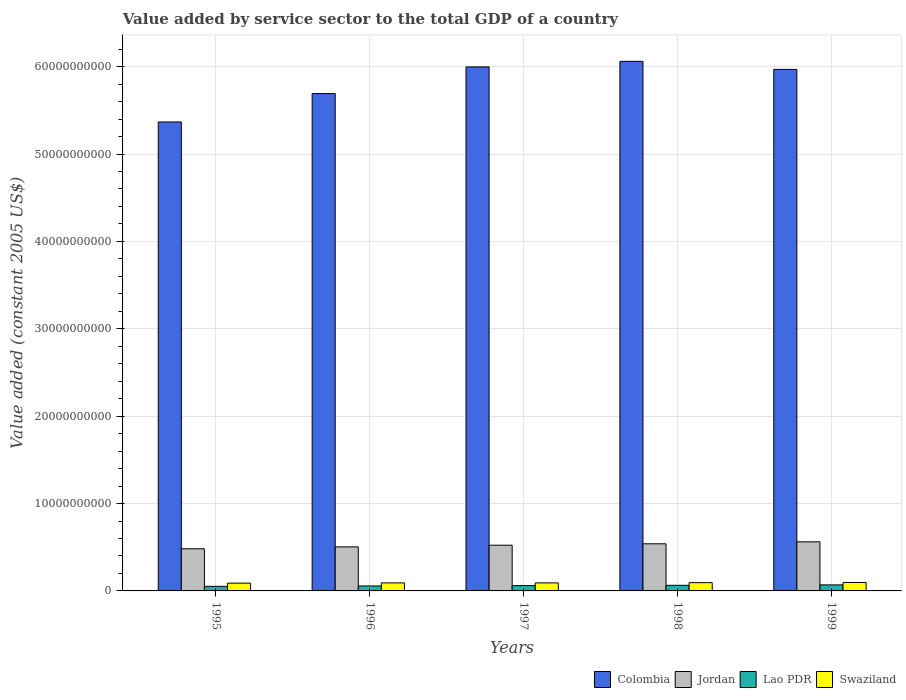How many different coloured bars are there?
Keep it short and to the point. 4. Are the number of bars per tick equal to the number of legend labels?
Your answer should be compact. Yes. Are the number of bars on each tick of the X-axis equal?
Provide a short and direct response. Yes. What is the label of the 3rd group of bars from the left?
Provide a succinct answer. 1997. What is the value added by service sector in Colombia in 1997?
Provide a succinct answer. 6.00e+1. Across all years, what is the maximum value added by service sector in Colombia?
Your answer should be compact. 6.06e+1. Across all years, what is the minimum value added by service sector in Swaziland?
Your answer should be very brief. 8.89e+08. What is the total value added by service sector in Lao PDR in the graph?
Make the answer very short. 3.04e+09. What is the difference between the value added by service sector in Colombia in 1996 and that in 1999?
Offer a very short reply. -2.77e+09. What is the difference between the value added by service sector in Colombia in 1998 and the value added by service sector in Lao PDR in 1999?
Offer a terse response. 5.99e+1. What is the average value added by service sector in Lao PDR per year?
Make the answer very short. 6.07e+08. In the year 1997, what is the difference between the value added by service sector in Swaziland and value added by service sector in Jordan?
Keep it short and to the point. -4.31e+09. In how many years, is the value added by service sector in Lao PDR greater than 8000000000 US$?
Give a very brief answer. 0. What is the ratio of the value added by service sector in Swaziland in 1995 to that in 1997?
Provide a succinct answer. 0.97. Is the value added by service sector in Lao PDR in 1997 less than that in 1999?
Ensure brevity in your answer.  Yes. Is the difference between the value added by service sector in Swaziland in 1996 and 1999 greater than the difference between the value added by service sector in Jordan in 1996 and 1999?
Ensure brevity in your answer.  Yes. What is the difference between the highest and the second highest value added by service sector in Colombia?
Make the answer very short. 6.36e+08. What is the difference between the highest and the lowest value added by service sector in Lao PDR?
Offer a very short reply. 1.65e+08. Is it the case that in every year, the sum of the value added by service sector in Swaziland and value added by service sector in Jordan is greater than the sum of value added by service sector in Colombia and value added by service sector in Lao PDR?
Ensure brevity in your answer.  No. What does the 3rd bar from the left in 1995 represents?
Provide a short and direct response. Lao PDR. What does the 1st bar from the right in 1997 represents?
Your answer should be compact. Swaziland. How many bars are there?
Your answer should be very brief. 20. Are all the bars in the graph horizontal?
Offer a very short reply. No. How many years are there in the graph?
Your response must be concise. 5. What is the difference between two consecutive major ticks on the Y-axis?
Give a very brief answer. 1.00e+1. Does the graph contain any zero values?
Make the answer very short. No. How many legend labels are there?
Keep it short and to the point. 4. What is the title of the graph?
Offer a very short reply. Value added by service sector to the total GDP of a country. What is the label or title of the Y-axis?
Your answer should be very brief. Value added (constant 2005 US$). What is the Value added (constant 2005 US$) in Colombia in 1995?
Offer a terse response. 5.37e+1. What is the Value added (constant 2005 US$) of Jordan in 1995?
Your response must be concise. 4.82e+09. What is the Value added (constant 2005 US$) of Lao PDR in 1995?
Provide a short and direct response. 5.25e+08. What is the Value added (constant 2005 US$) in Swaziland in 1995?
Your response must be concise. 8.89e+08. What is the Value added (constant 2005 US$) of Colombia in 1996?
Give a very brief answer. 5.69e+1. What is the Value added (constant 2005 US$) of Jordan in 1996?
Offer a very short reply. 5.04e+09. What is the Value added (constant 2005 US$) of Lao PDR in 1996?
Your answer should be compact. 5.68e+08. What is the Value added (constant 2005 US$) of Swaziland in 1996?
Your response must be concise. 9.19e+08. What is the Value added (constant 2005 US$) in Colombia in 1997?
Your answer should be very brief. 6.00e+1. What is the Value added (constant 2005 US$) in Jordan in 1997?
Your answer should be compact. 5.23e+09. What is the Value added (constant 2005 US$) in Lao PDR in 1997?
Provide a short and direct response. 6.11e+08. What is the Value added (constant 2005 US$) of Swaziland in 1997?
Provide a short and direct response. 9.18e+08. What is the Value added (constant 2005 US$) of Colombia in 1998?
Offer a terse response. 6.06e+1. What is the Value added (constant 2005 US$) of Jordan in 1998?
Offer a terse response. 5.39e+09. What is the Value added (constant 2005 US$) of Lao PDR in 1998?
Your response must be concise. 6.41e+08. What is the Value added (constant 2005 US$) in Swaziland in 1998?
Make the answer very short. 9.46e+08. What is the Value added (constant 2005 US$) of Colombia in 1999?
Give a very brief answer. 5.97e+1. What is the Value added (constant 2005 US$) in Jordan in 1999?
Keep it short and to the point. 5.62e+09. What is the Value added (constant 2005 US$) of Lao PDR in 1999?
Make the answer very short. 6.90e+08. What is the Value added (constant 2005 US$) of Swaziland in 1999?
Keep it short and to the point. 9.68e+08. Across all years, what is the maximum Value added (constant 2005 US$) in Colombia?
Your answer should be very brief. 6.06e+1. Across all years, what is the maximum Value added (constant 2005 US$) in Jordan?
Give a very brief answer. 5.62e+09. Across all years, what is the maximum Value added (constant 2005 US$) of Lao PDR?
Give a very brief answer. 6.90e+08. Across all years, what is the maximum Value added (constant 2005 US$) of Swaziland?
Your answer should be compact. 9.68e+08. Across all years, what is the minimum Value added (constant 2005 US$) of Colombia?
Keep it short and to the point. 5.37e+1. Across all years, what is the minimum Value added (constant 2005 US$) of Jordan?
Provide a short and direct response. 4.82e+09. Across all years, what is the minimum Value added (constant 2005 US$) in Lao PDR?
Provide a succinct answer. 5.25e+08. Across all years, what is the minimum Value added (constant 2005 US$) in Swaziland?
Provide a succinct answer. 8.89e+08. What is the total Value added (constant 2005 US$) of Colombia in the graph?
Your response must be concise. 2.91e+11. What is the total Value added (constant 2005 US$) in Jordan in the graph?
Your answer should be compact. 2.61e+1. What is the total Value added (constant 2005 US$) of Lao PDR in the graph?
Provide a short and direct response. 3.04e+09. What is the total Value added (constant 2005 US$) in Swaziland in the graph?
Offer a terse response. 4.64e+09. What is the difference between the Value added (constant 2005 US$) of Colombia in 1995 and that in 1996?
Provide a short and direct response. -3.25e+09. What is the difference between the Value added (constant 2005 US$) in Jordan in 1995 and that in 1996?
Your response must be concise. -2.20e+08. What is the difference between the Value added (constant 2005 US$) in Lao PDR in 1995 and that in 1996?
Offer a terse response. -4.25e+07. What is the difference between the Value added (constant 2005 US$) of Swaziland in 1995 and that in 1996?
Offer a terse response. -3.01e+07. What is the difference between the Value added (constant 2005 US$) of Colombia in 1995 and that in 1997?
Offer a very short reply. -6.30e+09. What is the difference between the Value added (constant 2005 US$) of Jordan in 1995 and that in 1997?
Your answer should be compact. -4.09e+08. What is the difference between the Value added (constant 2005 US$) of Lao PDR in 1995 and that in 1997?
Your response must be concise. -8.52e+07. What is the difference between the Value added (constant 2005 US$) of Swaziland in 1995 and that in 1997?
Your response must be concise. -2.96e+07. What is the difference between the Value added (constant 2005 US$) of Colombia in 1995 and that in 1998?
Your answer should be very brief. -6.94e+09. What is the difference between the Value added (constant 2005 US$) of Jordan in 1995 and that in 1998?
Ensure brevity in your answer.  -5.69e+08. What is the difference between the Value added (constant 2005 US$) in Lao PDR in 1995 and that in 1998?
Provide a succinct answer. -1.15e+08. What is the difference between the Value added (constant 2005 US$) in Swaziland in 1995 and that in 1998?
Offer a very short reply. -5.75e+07. What is the difference between the Value added (constant 2005 US$) in Colombia in 1995 and that in 1999?
Your answer should be compact. -6.02e+09. What is the difference between the Value added (constant 2005 US$) in Jordan in 1995 and that in 1999?
Your response must be concise. -7.94e+08. What is the difference between the Value added (constant 2005 US$) in Lao PDR in 1995 and that in 1999?
Your answer should be very brief. -1.65e+08. What is the difference between the Value added (constant 2005 US$) in Swaziland in 1995 and that in 1999?
Offer a terse response. -7.91e+07. What is the difference between the Value added (constant 2005 US$) in Colombia in 1996 and that in 1997?
Offer a terse response. -3.05e+09. What is the difference between the Value added (constant 2005 US$) of Jordan in 1996 and that in 1997?
Your answer should be very brief. -1.90e+08. What is the difference between the Value added (constant 2005 US$) of Lao PDR in 1996 and that in 1997?
Make the answer very short. -4.27e+07. What is the difference between the Value added (constant 2005 US$) of Swaziland in 1996 and that in 1997?
Make the answer very short. 4.19e+05. What is the difference between the Value added (constant 2005 US$) of Colombia in 1996 and that in 1998?
Keep it short and to the point. -3.69e+09. What is the difference between the Value added (constant 2005 US$) in Jordan in 1996 and that in 1998?
Your answer should be compact. -3.49e+08. What is the difference between the Value added (constant 2005 US$) of Lao PDR in 1996 and that in 1998?
Provide a short and direct response. -7.30e+07. What is the difference between the Value added (constant 2005 US$) in Swaziland in 1996 and that in 1998?
Provide a succinct answer. -2.75e+07. What is the difference between the Value added (constant 2005 US$) of Colombia in 1996 and that in 1999?
Make the answer very short. -2.77e+09. What is the difference between the Value added (constant 2005 US$) of Jordan in 1996 and that in 1999?
Ensure brevity in your answer.  -5.74e+08. What is the difference between the Value added (constant 2005 US$) in Lao PDR in 1996 and that in 1999?
Offer a very short reply. -1.22e+08. What is the difference between the Value added (constant 2005 US$) in Swaziland in 1996 and that in 1999?
Keep it short and to the point. -4.91e+07. What is the difference between the Value added (constant 2005 US$) in Colombia in 1997 and that in 1998?
Provide a short and direct response. -6.36e+08. What is the difference between the Value added (constant 2005 US$) of Jordan in 1997 and that in 1998?
Keep it short and to the point. -1.59e+08. What is the difference between the Value added (constant 2005 US$) of Lao PDR in 1997 and that in 1998?
Provide a short and direct response. -3.03e+07. What is the difference between the Value added (constant 2005 US$) of Swaziland in 1997 and that in 1998?
Your answer should be compact. -2.79e+07. What is the difference between the Value added (constant 2005 US$) of Colombia in 1997 and that in 1999?
Ensure brevity in your answer.  2.85e+08. What is the difference between the Value added (constant 2005 US$) in Jordan in 1997 and that in 1999?
Give a very brief answer. -3.85e+08. What is the difference between the Value added (constant 2005 US$) of Lao PDR in 1997 and that in 1999?
Provide a succinct answer. -7.95e+07. What is the difference between the Value added (constant 2005 US$) of Swaziland in 1997 and that in 1999?
Your answer should be compact. -4.95e+07. What is the difference between the Value added (constant 2005 US$) in Colombia in 1998 and that in 1999?
Offer a very short reply. 9.21e+08. What is the difference between the Value added (constant 2005 US$) of Jordan in 1998 and that in 1999?
Offer a very short reply. -2.25e+08. What is the difference between the Value added (constant 2005 US$) in Lao PDR in 1998 and that in 1999?
Keep it short and to the point. -4.93e+07. What is the difference between the Value added (constant 2005 US$) of Swaziland in 1998 and that in 1999?
Your answer should be very brief. -2.16e+07. What is the difference between the Value added (constant 2005 US$) of Colombia in 1995 and the Value added (constant 2005 US$) of Jordan in 1996?
Your answer should be compact. 4.86e+1. What is the difference between the Value added (constant 2005 US$) in Colombia in 1995 and the Value added (constant 2005 US$) in Lao PDR in 1996?
Your answer should be very brief. 5.31e+1. What is the difference between the Value added (constant 2005 US$) in Colombia in 1995 and the Value added (constant 2005 US$) in Swaziland in 1996?
Your response must be concise. 5.27e+1. What is the difference between the Value added (constant 2005 US$) of Jordan in 1995 and the Value added (constant 2005 US$) of Lao PDR in 1996?
Make the answer very short. 4.25e+09. What is the difference between the Value added (constant 2005 US$) of Jordan in 1995 and the Value added (constant 2005 US$) of Swaziland in 1996?
Your answer should be compact. 3.90e+09. What is the difference between the Value added (constant 2005 US$) of Lao PDR in 1995 and the Value added (constant 2005 US$) of Swaziland in 1996?
Ensure brevity in your answer.  -3.93e+08. What is the difference between the Value added (constant 2005 US$) in Colombia in 1995 and the Value added (constant 2005 US$) in Jordan in 1997?
Keep it short and to the point. 4.84e+1. What is the difference between the Value added (constant 2005 US$) in Colombia in 1995 and the Value added (constant 2005 US$) in Lao PDR in 1997?
Offer a very short reply. 5.31e+1. What is the difference between the Value added (constant 2005 US$) in Colombia in 1995 and the Value added (constant 2005 US$) in Swaziland in 1997?
Offer a very short reply. 5.28e+1. What is the difference between the Value added (constant 2005 US$) of Jordan in 1995 and the Value added (constant 2005 US$) of Lao PDR in 1997?
Offer a very short reply. 4.21e+09. What is the difference between the Value added (constant 2005 US$) of Jordan in 1995 and the Value added (constant 2005 US$) of Swaziland in 1997?
Offer a terse response. 3.90e+09. What is the difference between the Value added (constant 2005 US$) of Lao PDR in 1995 and the Value added (constant 2005 US$) of Swaziland in 1997?
Ensure brevity in your answer.  -3.93e+08. What is the difference between the Value added (constant 2005 US$) in Colombia in 1995 and the Value added (constant 2005 US$) in Jordan in 1998?
Offer a very short reply. 4.83e+1. What is the difference between the Value added (constant 2005 US$) of Colombia in 1995 and the Value added (constant 2005 US$) of Lao PDR in 1998?
Give a very brief answer. 5.30e+1. What is the difference between the Value added (constant 2005 US$) of Colombia in 1995 and the Value added (constant 2005 US$) of Swaziland in 1998?
Offer a very short reply. 5.27e+1. What is the difference between the Value added (constant 2005 US$) in Jordan in 1995 and the Value added (constant 2005 US$) in Lao PDR in 1998?
Your response must be concise. 4.18e+09. What is the difference between the Value added (constant 2005 US$) of Jordan in 1995 and the Value added (constant 2005 US$) of Swaziland in 1998?
Offer a very short reply. 3.88e+09. What is the difference between the Value added (constant 2005 US$) of Lao PDR in 1995 and the Value added (constant 2005 US$) of Swaziland in 1998?
Give a very brief answer. -4.21e+08. What is the difference between the Value added (constant 2005 US$) of Colombia in 1995 and the Value added (constant 2005 US$) of Jordan in 1999?
Your answer should be compact. 4.81e+1. What is the difference between the Value added (constant 2005 US$) of Colombia in 1995 and the Value added (constant 2005 US$) of Lao PDR in 1999?
Provide a succinct answer. 5.30e+1. What is the difference between the Value added (constant 2005 US$) of Colombia in 1995 and the Value added (constant 2005 US$) of Swaziland in 1999?
Ensure brevity in your answer.  5.27e+1. What is the difference between the Value added (constant 2005 US$) in Jordan in 1995 and the Value added (constant 2005 US$) in Lao PDR in 1999?
Make the answer very short. 4.13e+09. What is the difference between the Value added (constant 2005 US$) in Jordan in 1995 and the Value added (constant 2005 US$) in Swaziland in 1999?
Provide a succinct answer. 3.85e+09. What is the difference between the Value added (constant 2005 US$) of Lao PDR in 1995 and the Value added (constant 2005 US$) of Swaziland in 1999?
Keep it short and to the point. -4.42e+08. What is the difference between the Value added (constant 2005 US$) in Colombia in 1996 and the Value added (constant 2005 US$) in Jordan in 1997?
Keep it short and to the point. 5.17e+1. What is the difference between the Value added (constant 2005 US$) in Colombia in 1996 and the Value added (constant 2005 US$) in Lao PDR in 1997?
Give a very brief answer. 5.63e+1. What is the difference between the Value added (constant 2005 US$) of Colombia in 1996 and the Value added (constant 2005 US$) of Swaziland in 1997?
Make the answer very short. 5.60e+1. What is the difference between the Value added (constant 2005 US$) in Jordan in 1996 and the Value added (constant 2005 US$) in Lao PDR in 1997?
Your response must be concise. 4.43e+09. What is the difference between the Value added (constant 2005 US$) of Jordan in 1996 and the Value added (constant 2005 US$) of Swaziland in 1997?
Offer a very short reply. 4.12e+09. What is the difference between the Value added (constant 2005 US$) of Lao PDR in 1996 and the Value added (constant 2005 US$) of Swaziland in 1997?
Make the answer very short. -3.51e+08. What is the difference between the Value added (constant 2005 US$) of Colombia in 1996 and the Value added (constant 2005 US$) of Jordan in 1998?
Provide a short and direct response. 5.15e+1. What is the difference between the Value added (constant 2005 US$) of Colombia in 1996 and the Value added (constant 2005 US$) of Lao PDR in 1998?
Your answer should be compact. 5.63e+1. What is the difference between the Value added (constant 2005 US$) of Colombia in 1996 and the Value added (constant 2005 US$) of Swaziland in 1998?
Your answer should be compact. 5.60e+1. What is the difference between the Value added (constant 2005 US$) in Jordan in 1996 and the Value added (constant 2005 US$) in Lao PDR in 1998?
Give a very brief answer. 4.40e+09. What is the difference between the Value added (constant 2005 US$) in Jordan in 1996 and the Value added (constant 2005 US$) in Swaziland in 1998?
Offer a very short reply. 4.10e+09. What is the difference between the Value added (constant 2005 US$) of Lao PDR in 1996 and the Value added (constant 2005 US$) of Swaziland in 1998?
Offer a very short reply. -3.78e+08. What is the difference between the Value added (constant 2005 US$) in Colombia in 1996 and the Value added (constant 2005 US$) in Jordan in 1999?
Ensure brevity in your answer.  5.13e+1. What is the difference between the Value added (constant 2005 US$) in Colombia in 1996 and the Value added (constant 2005 US$) in Lao PDR in 1999?
Offer a very short reply. 5.62e+1. What is the difference between the Value added (constant 2005 US$) of Colombia in 1996 and the Value added (constant 2005 US$) of Swaziland in 1999?
Give a very brief answer. 5.59e+1. What is the difference between the Value added (constant 2005 US$) of Jordan in 1996 and the Value added (constant 2005 US$) of Lao PDR in 1999?
Your response must be concise. 4.35e+09. What is the difference between the Value added (constant 2005 US$) in Jordan in 1996 and the Value added (constant 2005 US$) in Swaziland in 1999?
Your answer should be compact. 4.07e+09. What is the difference between the Value added (constant 2005 US$) of Lao PDR in 1996 and the Value added (constant 2005 US$) of Swaziland in 1999?
Make the answer very short. -4.00e+08. What is the difference between the Value added (constant 2005 US$) of Colombia in 1997 and the Value added (constant 2005 US$) of Jordan in 1998?
Your answer should be compact. 5.46e+1. What is the difference between the Value added (constant 2005 US$) of Colombia in 1997 and the Value added (constant 2005 US$) of Lao PDR in 1998?
Give a very brief answer. 5.93e+1. What is the difference between the Value added (constant 2005 US$) in Colombia in 1997 and the Value added (constant 2005 US$) in Swaziland in 1998?
Your answer should be compact. 5.90e+1. What is the difference between the Value added (constant 2005 US$) in Jordan in 1997 and the Value added (constant 2005 US$) in Lao PDR in 1998?
Your response must be concise. 4.59e+09. What is the difference between the Value added (constant 2005 US$) in Jordan in 1997 and the Value added (constant 2005 US$) in Swaziland in 1998?
Your response must be concise. 4.29e+09. What is the difference between the Value added (constant 2005 US$) in Lao PDR in 1997 and the Value added (constant 2005 US$) in Swaziland in 1998?
Your answer should be very brief. -3.36e+08. What is the difference between the Value added (constant 2005 US$) of Colombia in 1997 and the Value added (constant 2005 US$) of Jordan in 1999?
Your answer should be compact. 5.44e+1. What is the difference between the Value added (constant 2005 US$) of Colombia in 1997 and the Value added (constant 2005 US$) of Lao PDR in 1999?
Offer a very short reply. 5.93e+1. What is the difference between the Value added (constant 2005 US$) in Colombia in 1997 and the Value added (constant 2005 US$) in Swaziland in 1999?
Your response must be concise. 5.90e+1. What is the difference between the Value added (constant 2005 US$) in Jordan in 1997 and the Value added (constant 2005 US$) in Lao PDR in 1999?
Give a very brief answer. 4.54e+09. What is the difference between the Value added (constant 2005 US$) of Jordan in 1997 and the Value added (constant 2005 US$) of Swaziland in 1999?
Provide a short and direct response. 4.26e+09. What is the difference between the Value added (constant 2005 US$) of Lao PDR in 1997 and the Value added (constant 2005 US$) of Swaziland in 1999?
Your answer should be very brief. -3.57e+08. What is the difference between the Value added (constant 2005 US$) in Colombia in 1998 and the Value added (constant 2005 US$) in Jordan in 1999?
Ensure brevity in your answer.  5.50e+1. What is the difference between the Value added (constant 2005 US$) of Colombia in 1998 and the Value added (constant 2005 US$) of Lao PDR in 1999?
Offer a very short reply. 5.99e+1. What is the difference between the Value added (constant 2005 US$) in Colombia in 1998 and the Value added (constant 2005 US$) in Swaziland in 1999?
Provide a short and direct response. 5.96e+1. What is the difference between the Value added (constant 2005 US$) in Jordan in 1998 and the Value added (constant 2005 US$) in Lao PDR in 1999?
Your answer should be compact. 4.70e+09. What is the difference between the Value added (constant 2005 US$) of Jordan in 1998 and the Value added (constant 2005 US$) of Swaziland in 1999?
Keep it short and to the point. 4.42e+09. What is the difference between the Value added (constant 2005 US$) in Lao PDR in 1998 and the Value added (constant 2005 US$) in Swaziland in 1999?
Your response must be concise. -3.27e+08. What is the average Value added (constant 2005 US$) in Colombia per year?
Offer a terse response. 5.82e+1. What is the average Value added (constant 2005 US$) of Jordan per year?
Provide a short and direct response. 5.22e+09. What is the average Value added (constant 2005 US$) of Lao PDR per year?
Provide a succinct answer. 6.07e+08. What is the average Value added (constant 2005 US$) in Swaziland per year?
Make the answer very short. 9.28e+08. In the year 1995, what is the difference between the Value added (constant 2005 US$) in Colombia and Value added (constant 2005 US$) in Jordan?
Offer a very short reply. 4.88e+1. In the year 1995, what is the difference between the Value added (constant 2005 US$) of Colombia and Value added (constant 2005 US$) of Lao PDR?
Make the answer very short. 5.31e+1. In the year 1995, what is the difference between the Value added (constant 2005 US$) in Colombia and Value added (constant 2005 US$) in Swaziland?
Provide a short and direct response. 5.28e+1. In the year 1995, what is the difference between the Value added (constant 2005 US$) in Jordan and Value added (constant 2005 US$) in Lao PDR?
Make the answer very short. 4.30e+09. In the year 1995, what is the difference between the Value added (constant 2005 US$) in Jordan and Value added (constant 2005 US$) in Swaziland?
Provide a succinct answer. 3.93e+09. In the year 1995, what is the difference between the Value added (constant 2005 US$) in Lao PDR and Value added (constant 2005 US$) in Swaziland?
Your answer should be very brief. -3.63e+08. In the year 1996, what is the difference between the Value added (constant 2005 US$) of Colombia and Value added (constant 2005 US$) of Jordan?
Your answer should be very brief. 5.19e+1. In the year 1996, what is the difference between the Value added (constant 2005 US$) in Colombia and Value added (constant 2005 US$) in Lao PDR?
Make the answer very short. 5.63e+1. In the year 1996, what is the difference between the Value added (constant 2005 US$) of Colombia and Value added (constant 2005 US$) of Swaziland?
Your response must be concise. 5.60e+1. In the year 1996, what is the difference between the Value added (constant 2005 US$) in Jordan and Value added (constant 2005 US$) in Lao PDR?
Provide a succinct answer. 4.47e+09. In the year 1996, what is the difference between the Value added (constant 2005 US$) in Jordan and Value added (constant 2005 US$) in Swaziland?
Provide a short and direct response. 4.12e+09. In the year 1996, what is the difference between the Value added (constant 2005 US$) in Lao PDR and Value added (constant 2005 US$) in Swaziland?
Provide a short and direct response. -3.51e+08. In the year 1997, what is the difference between the Value added (constant 2005 US$) of Colombia and Value added (constant 2005 US$) of Jordan?
Keep it short and to the point. 5.47e+1. In the year 1997, what is the difference between the Value added (constant 2005 US$) in Colombia and Value added (constant 2005 US$) in Lao PDR?
Offer a terse response. 5.94e+1. In the year 1997, what is the difference between the Value added (constant 2005 US$) of Colombia and Value added (constant 2005 US$) of Swaziland?
Keep it short and to the point. 5.91e+1. In the year 1997, what is the difference between the Value added (constant 2005 US$) in Jordan and Value added (constant 2005 US$) in Lao PDR?
Make the answer very short. 4.62e+09. In the year 1997, what is the difference between the Value added (constant 2005 US$) of Jordan and Value added (constant 2005 US$) of Swaziland?
Offer a terse response. 4.31e+09. In the year 1997, what is the difference between the Value added (constant 2005 US$) of Lao PDR and Value added (constant 2005 US$) of Swaziland?
Offer a very short reply. -3.08e+08. In the year 1998, what is the difference between the Value added (constant 2005 US$) of Colombia and Value added (constant 2005 US$) of Jordan?
Offer a very short reply. 5.52e+1. In the year 1998, what is the difference between the Value added (constant 2005 US$) of Colombia and Value added (constant 2005 US$) of Lao PDR?
Make the answer very short. 6.00e+1. In the year 1998, what is the difference between the Value added (constant 2005 US$) of Colombia and Value added (constant 2005 US$) of Swaziland?
Offer a very short reply. 5.97e+1. In the year 1998, what is the difference between the Value added (constant 2005 US$) in Jordan and Value added (constant 2005 US$) in Lao PDR?
Your response must be concise. 4.75e+09. In the year 1998, what is the difference between the Value added (constant 2005 US$) of Jordan and Value added (constant 2005 US$) of Swaziland?
Provide a short and direct response. 4.45e+09. In the year 1998, what is the difference between the Value added (constant 2005 US$) in Lao PDR and Value added (constant 2005 US$) in Swaziland?
Provide a succinct answer. -3.05e+08. In the year 1999, what is the difference between the Value added (constant 2005 US$) of Colombia and Value added (constant 2005 US$) of Jordan?
Your answer should be compact. 5.41e+1. In the year 1999, what is the difference between the Value added (constant 2005 US$) of Colombia and Value added (constant 2005 US$) of Lao PDR?
Make the answer very short. 5.90e+1. In the year 1999, what is the difference between the Value added (constant 2005 US$) in Colombia and Value added (constant 2005 US$) in Swaziland?
Your answer should be very brief. 5.87e+1. In the year 1999, what is the difference between the Value added (constant 2005 US$) in Jordan and Value added (constant 2005 US$) in Lao PDR?
Give a very brief answer. 4.93e+09. In the year 1999, what is the difference between the Value added (constant 2005 US$) in Jordan and Value added (constant 2005 US$) in Swaziland?
Make the answer very short. 4.65e+09. In the year 1999, what is the difference between the Value added (constant 2005 US$) of Lao PDR and Value added (constant 2005 US$) of Swaziland?
Offer a terse response. -2.78e+08. What is the ratio of the Value added (constant 2005 US$) in Colombia in 1995 to that in 1996?
Provide a succinct answer. 0.94. What is the ratio of the Value added (constant 2005 US$) in Jordan in 1995 to that in 1996?
Offer a terse response. 0.96. What is the ratio of the Value added (constant 2005 US$) of Lao PDR in 1995 to that in 1996?
Keep it short and to the point. 0.93. What is the ratio of the Value added (constant 2005 US$) of Swaziland in 1995 to that in 1996?
Offer a terse response. 0.97. What is the ratio of the Value added (constant 2005 US$) in Colombia in 1995 to that in 1997?
Offer a very short reply. 0.89. What is the ratio of the Value added (constant 2005 US$) in Jordan in 1995 to that in 1997?
Offer a terse response. 0.92. What is the ratio of the Value added (constant 2005 US$) of Lao PDR in 1995 to that in 1997?
Give a very brief answer. 0.86. What is the ratio of the Value added (constant 2005 US$) in Colombia in 1995 to that in 1998?
Ensure brevity in your answer.  0.89. What is the ratio of the Value added (constant 2005 US$) in Jordan in 1995 to that in 1998?
Your answer should be compact. 0.89. What is the ratio of the Value added (constant 2005 US$) in Lao PDR in 1995 to that in 1998?
Provide a short and direct response. 0.82. What is the ratio of the Value added (constant 2005 US$) in Swaziland in 1995 to that in 1998?
Provide a short and direct response. 0.94. What is the ratio of the Value added (constant 2005 US$) in Colombia in 1995 to that in 1999?
Provide a succinct answer. 0.9. What is the ratio of the Value added (constant 2005 US$) of Jordan in 1995 to that in 1999?
Your answer should be very brief. 0.86. What is the ratio of the Value added (constant 2005 US$) in Lao PDR in 1995 to that in 1999?
Ensure brevity in your answer.  0.76. What is the ratio of the Value added (constant 2005 US$) of Swaziland in 1995 to that in 1999?
Your response must be concise. 0.92. What is the ratio of the Value added (constant 2005 US$) in Colombia in 1996 to that in 1997?
Your answer should be very brief. 0.95. What is the ratio of the Value added (constant 2005 US$) of Jordan in 1996 to that in 1997?
Provide a succinct answer. 0.96. What is the ratio of the Value added (constant 2005 US$) of Swaziland in 1996 to that in 1997?
Keep it short and to the point. 1. What is the ratio of the Value added (constant 2005 US$) in Colombia in 1996 to that in 1998?
Offer a terse response. 0.94. What is the ratio of the Value added (constant 2005 US$) in Jordan in 1996 to that in 1998?
Ensure brevity in your answer.  0.94. What is the ratio of the Value added (constant 2005 US$) in Lao PDR in 1996 to that in 1998?
Offer a terse response. 0.89. What is the ratio of the Value added (constant 2005 US$) in Colombia in 1996 to that in 1999?
Your response must be concise. 0.95. What is the ratio of the Value added (constant 2005 US$) of Jordan in 1996 to that in 1999?
Make the answer very short. 0.9. What is the ratio of the Value added (constant 2005 US$) in Lao PDR in 1996 to that in 1999?
Your response must be concise. 0.82. What is the ratio of the Value added (constant 2005 US$) in Swaziland in 1996 to that in 1999?
Your answer should be very brief. 0.95. What is the ratio of the Value added (constant 2005 US$) of Colombia in 1997 to that in 1998?
Provide a succinct answer. 0.99. What is the ratio of the Value added (constant 2005 US$) in Jordan in 1997 to that in 1998?
Ensure brevity in your answer.  0.97. What is the ratio of the Value added (constant 2005 US$) in Lao PDR in 1997 to that in 1998?
Give a very brief answer. 0.95. What is the ratio of the Value added (constant 2005 US$) of Swaziland in 1997 to that in 1998?
Make the answer very short. 0.97. What is the ratio of the Value added (constant 2005 US$) of Jordan in 1997 to that in 1999?
Your answer should be compact. 0.93. What is the ratio of the Value added (constant 2005 US$) of Lao PDR in 1997 to that in 1999?
Keep it short and to the point. 0.88. What is the ratio of the Value added (constant 2005 US$) of Swaziland in 1997 to that in 1999?
Your answer should be compact. 0.95. What is the ratio of the Value added (constant 2005 US$) of Colombia in 1998 to that in 1999?
Provide a short and direct response. 1.02. What is the ratio of the Value added (constant 2005 US$) of Jordan in 1998 to that in 1999?
Offer a very short reply. 0.96. What is the ratio of the Value added (constant 2005 US$) of Swaziland in 1998 to that in 1999?
Ensure brevity in your answer.  0.98. What is the difference between the highest and the second highest Value added (constant 2005 US$) in Colombia?
Your answer should be compact. 6.36e+08. What is the difference between the highest and the second highest Value added (constant 2005 US$) in Jordan?
Your answer should be very brief. 2.25e+08. What is the difference between the highest and the second highest Value added (constant 2005 US$) of Lao PDR?
Provide a succinct answer. 4.93e+07. What is the difference between the highest and the second highest Value added (constant 2005 US$) of Swaziland?
Make the answer very short. 2.16e+07. What is the difference between the highest and the lowest Value added (constant 2005 US$) of Colombia?
Offer a terse response. 6.94e+09. What is the difference between the highest and the lowest Value added (constant 2005 US$) of Jordan?
Offer a terse response. 7.94e+08. What is the difference between the highest and the lowest Value added (constant 2005 US$) in Lao PDR?
Keep it short and to the point. 1.65e+08. What is the difference between the highest and the lowest Value added (constant 2005 US$) in Swaziland?
Offer a terse response. 7.91e+07. 